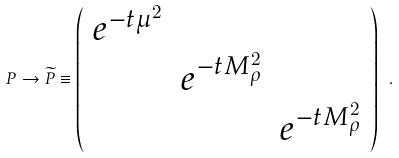<formula> <loc_0><loc_0><loc_500><loc_500>P \rightarrow \widetilde { P } \equiv \left ( \begin{array} { c c c } e ^ { - t \mu ^ { 2 } } & & \\ & e ^ { - t M _ { \rho } ^ { 2 } } & \\ & & e ^ { - t M _ { \rho } ^ { 2 } } \end{array} \right ) \ .</formula> 